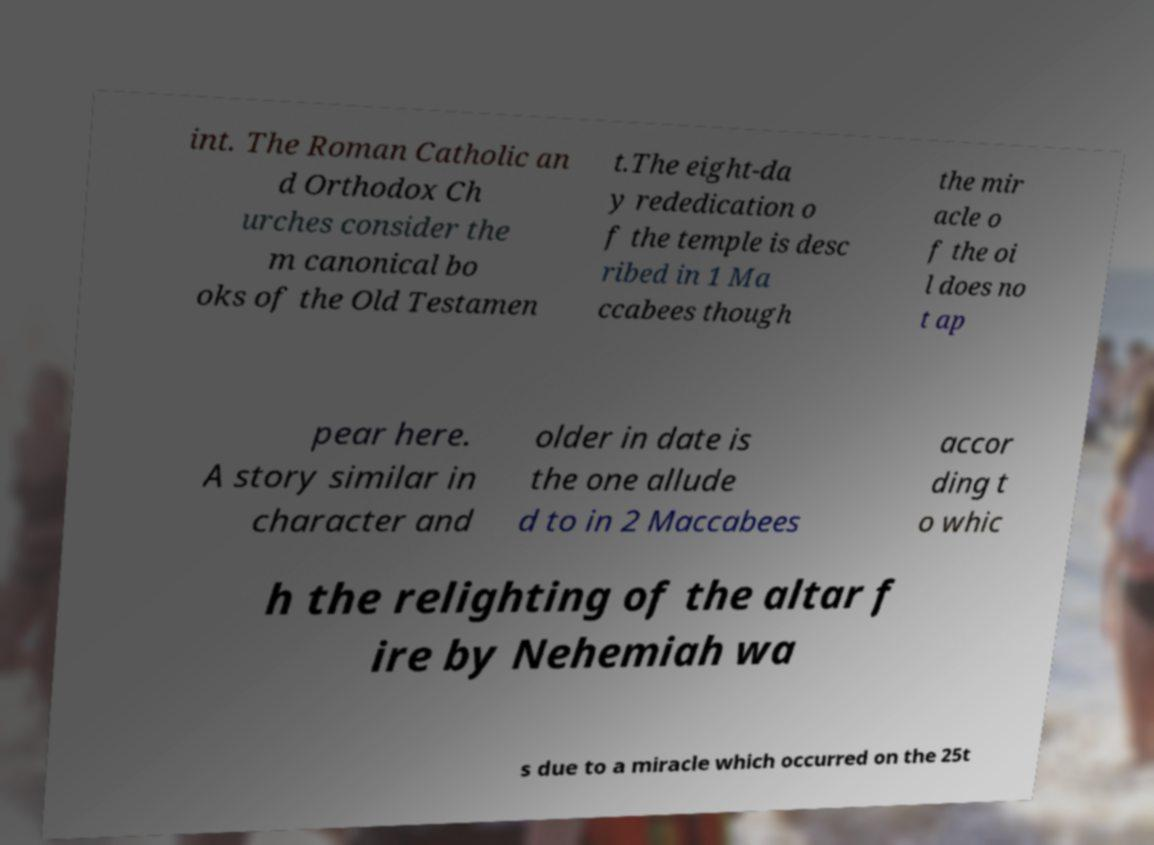Can you read and provide the text displayed in the image?This photo seems to have some interesting text. Can you extract and type it out for me? int. The Roman Catholic an d Orthodox Ch urches consider the m canonical bo oks of the Old Testamen t.The eight-da y rededication o f the temple is desc ribed in 1 Ma ccabees though the mir acle o f the oi l does no t ap pear here. A story similar in character and older in date is the one allude d to in 2 Maccabees accor ding t o whic h the relighting of the altar f ire by Nehemiah wa s due to a miracle which occurred on the 25t 